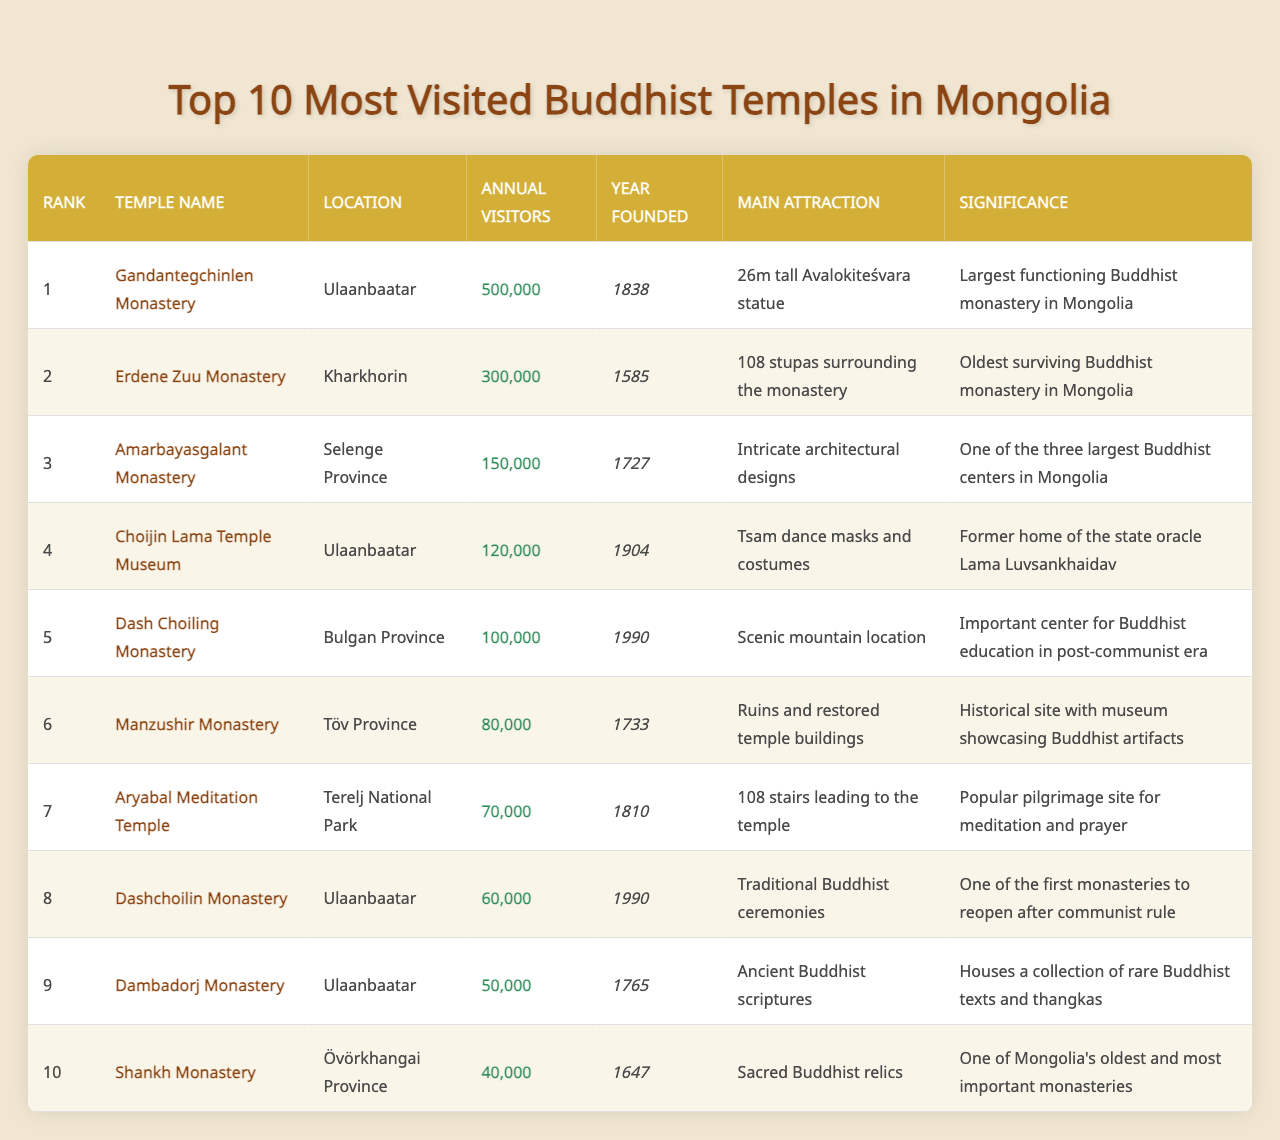What is the most visited Buddhist temple in Mongolia? The most visited temple can be found in the table under the "Rank" and "Temple Name" columns. The first entry states that Gandantegchinlen Monastery has 500,000 annual visitors, making it the top-ranked temple.
Answer: Gandantegchinlen Monastery Which temple has the main attraction of a 26m tall Avalokiteśvara statue? By scanning the "Main Attraction" column, we see that the temple associated with the 26m tall Avalokiteśvara statue is Gandantegchinlen Monastery.
Answer: Gandantegchinlen Monastery What year was the Erdene Zuu Monastery founded? The table lists the year founded for each temple. The entry for Erdene Zuu Monastery indicates it was established in 1585.
Answer: 1585 Is Dashchoilin Monastery located in Ulaanbaatar? By looking at the "Location" column, we can see that Dashchoilin Monastery is indeed listed as being located in Ulaanbaatar.
Answer: Yes How many annual visitors does the Amarbayasgalant Monastery receive? The "Annual Visitors" column shows that Amarbayasgalant Monastery receives 150,000 visitors each year.
Answer: 150,000 What is the significance of the Choijin Lama Temple Museum? The significance is provided in the table next to the temple name. It states that Choijin Lama Temple Museum was formerly the home of the state oracle Lama Luvsankhaidav.
Answer: Former home of the state oracle Lama Luvsankhaidav What is the average number of annual visitors for the top three most visited temples? To calculate the average, we find the total number of visitors for the top three temples (500,000 + 300,000 + 150,000 = 950,000). Dividing by 3 gives us 950,000 / 3 ≈ 316,667.
Answer: 316,667 Which temple has the most recent founding year? By comparing the "Year Founded" values in the table, Dash Choiling Monastery is listed with the year 1990, making it the most recent temple founded.
Answer: 1990 What is the main attraction of the Shankh Monastery? The "Main Attraction" column entry for Shankh Monastery indicates that it features sacred Buddhist relics.
Answer: Sacred Buddhist relics Which temple has the least number of annual visitors and what is that number? The table shows that Shankh Monastery has the least number of visitors with 40,000 annual visitors, as seen in the "Annual Visitors" column.
Answer: 40,000 What percentage of annual visitors does the Dambadorj Monastery have compared to the most visited temple? Dambadorj Monastery has 50,000 annual visitors and Gandantegchinlen Monastery has 500,000. The percentage is calculated as (50,000 / 500,000) * 100, which equals 10%.
Answer: 10% 